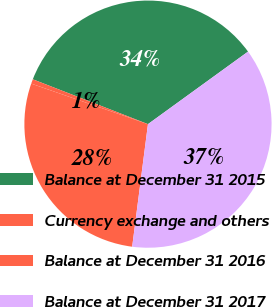<chart> <loc_0><loc_0><loc_500><loc_500><pie_chart><fcel>Balance at December 31 2015<fcel>Currency exchange and others<fcel>Balance at December 31 2016<fcel>Balance at December 31 2017<nl><fcel>34.11%<fcel>0.59%<fcel>28.28%<fcel>37.02%<nl></chart> 